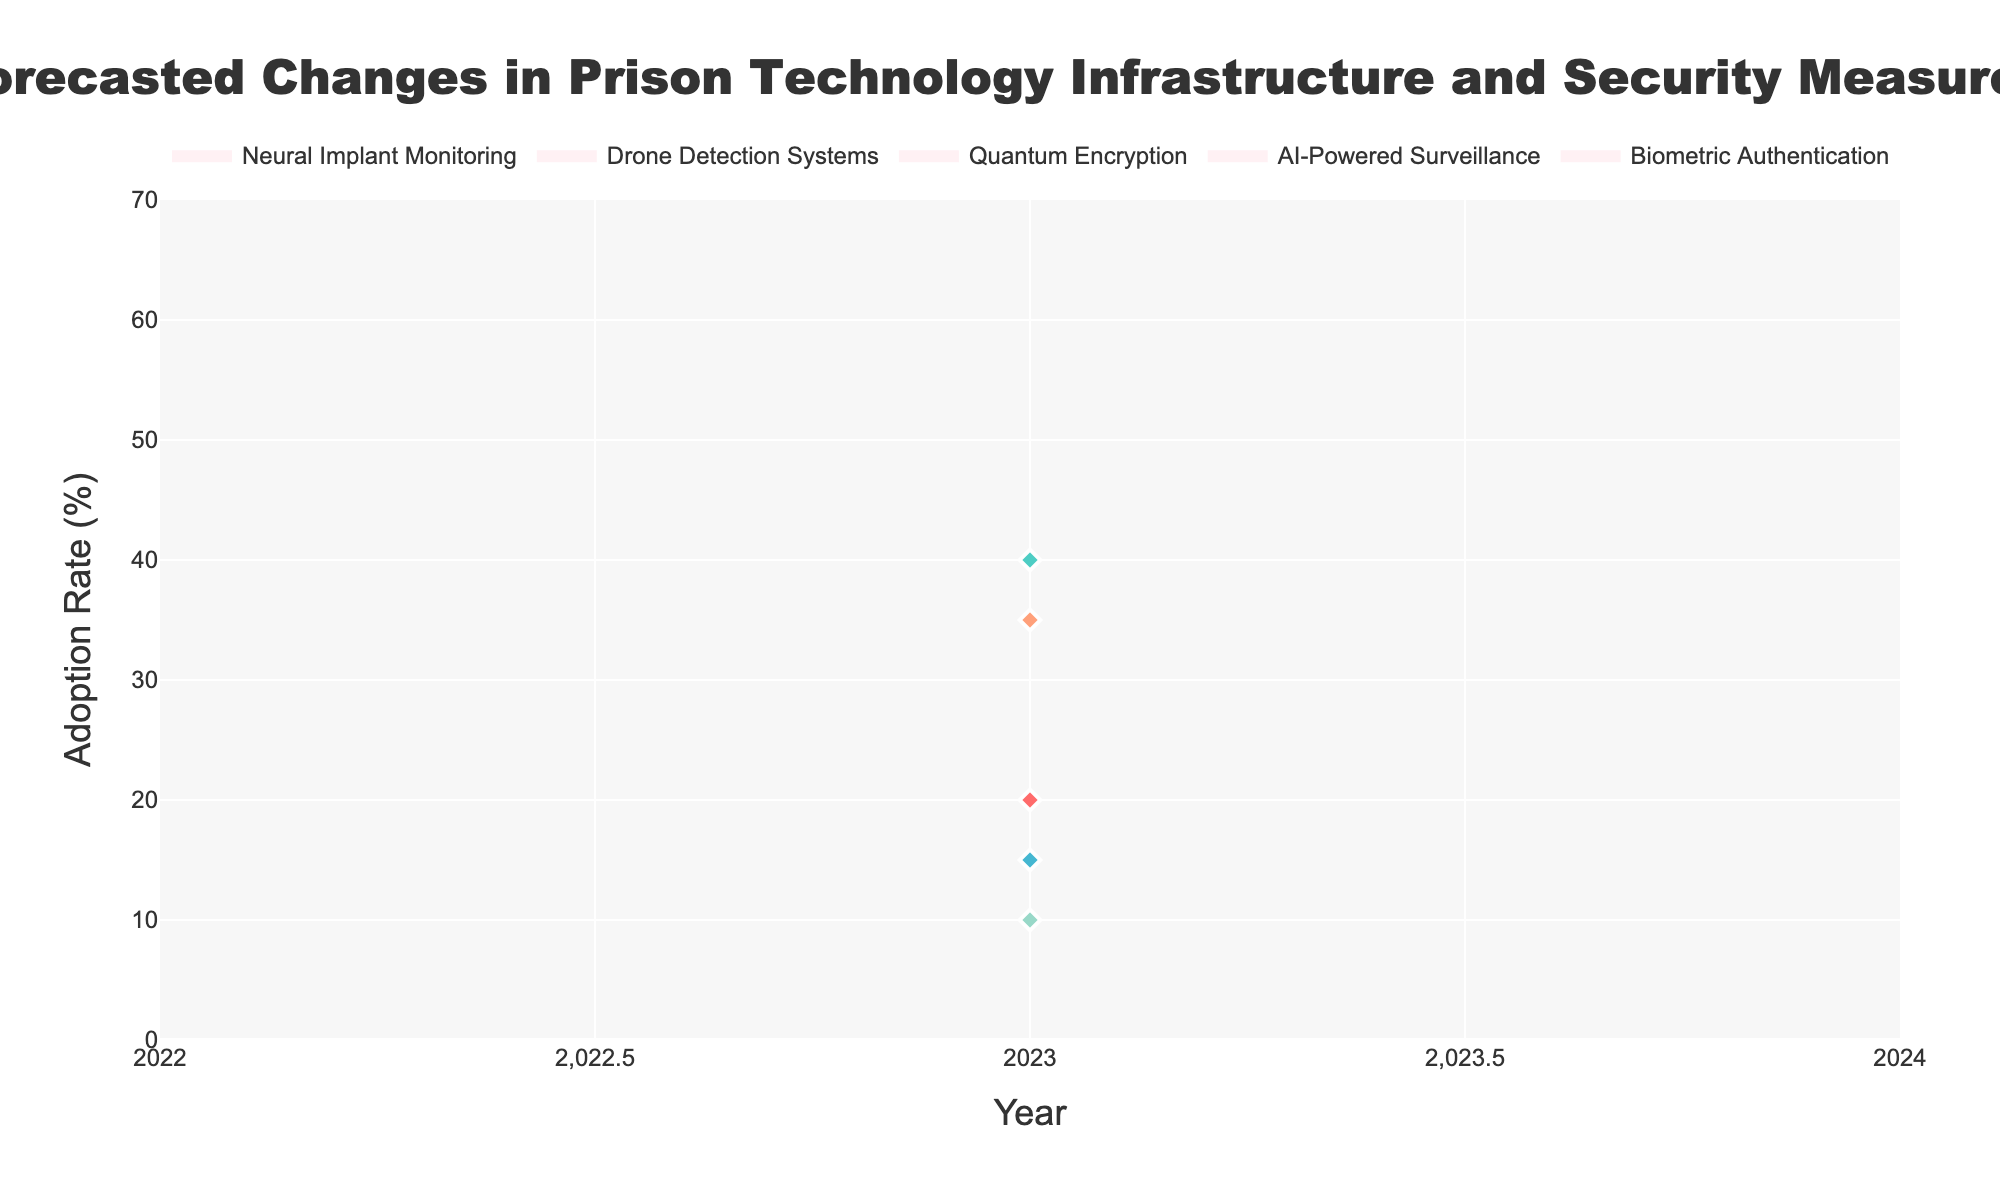What is the title of the figure? The title is written at the top of the figure.
Answer: Forecasted Changes in Prison Technology Infrastructure and Security Measures What is the range on the y-axis? The range of the y-axis is indicated by the lowest and highest values provided on the vertical axis.
Answer: 0 to 70 Which prison technology measure has the highest median forecasted adoption rate in 2028? Look at the x-axis for the year 2028 and find the median values for each measure. Compare them to determine which is highest.
Answer: AI-Powered Surveillance What is the forecasted median adoption rate for Neural Implant Monitoring in 2043? Find the median value for Neural Implant Monitoring in the year 2043.
Answer: 10% How does the adoption rate range for Biometric Authentication in 2023 compare to Drone Detection Systems in 2038? Compare the ranges from the low to high values for Biometric Authentication in 2023 and Drone Detection Systems in 2038.
Answer: 10-30% vs. 15-55% Which measure shows the lowest median adoption rate in 2033? Find the median values for the year 2033 and determine which one is the lowest among the measures.
Answer: Quantum Encryption Calculate the difference between the high and low forecasted adoption rates for AI-Powered Surveillance in 2028. Subtract the low value from the high value for AI-Powered Surveillance in 2028 (60 - 20).
Answer: 40% What is the expected range of adoption rates for Quantum Encryption in 2033? Look at the low and high forecasted values for Quantum Encryption in 2033.
Answer: 5-25% Between which years does Biometric Authentication maintain its presence on the chart? Identify the years on the x-axis where Biometric Authentication data points are present.
Answer: 2023 only Which technology measure shows the most significant increase in the median forecasted adoption rate from 2023 to 2028? Calculate the increase in median values from 2023 to 2028 for each measure and find the largest increase.
Answer: AI-Powered Surveillance 